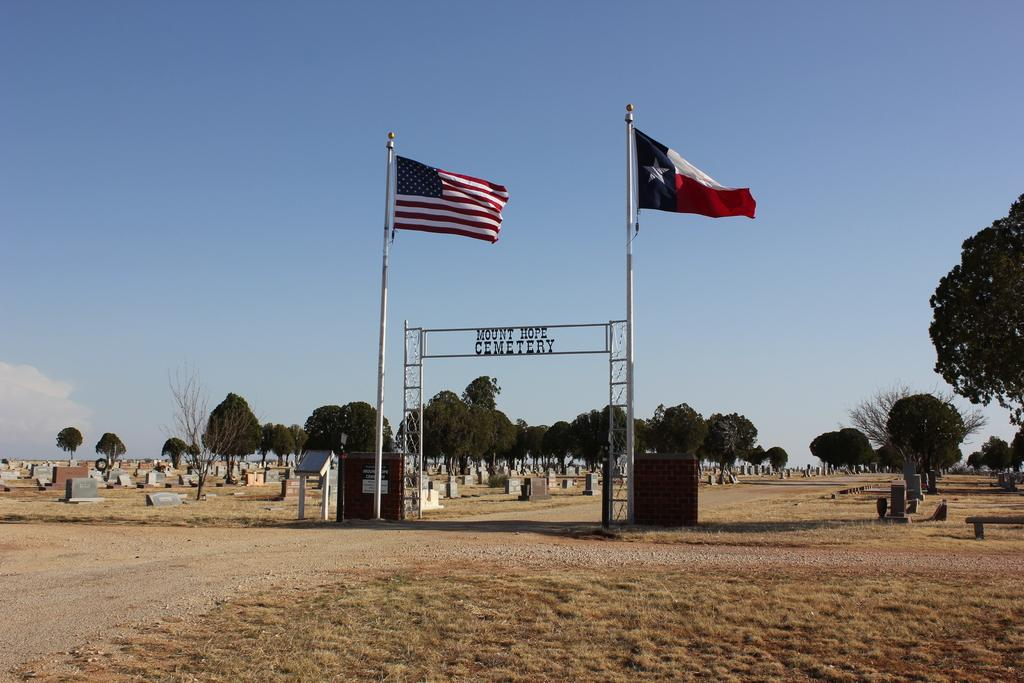How many flags are visible in the image? There are two flags in the image. What colors are present on the flags? The flags have blue, red, and white colors. What can be seen in the background of the image? There are trees and cemeteries in the background of the image. What is the color of the trees? The trees have green colors. What colors are present in the sky? The sky has white and blue colors. How many pins are holding the flags in the image? There is no mention of pins in the image, so we cannot determine the number of pins present. 